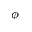<formula> <loc_0><loc_0><loc_500><loc_500>\phi</formula> 